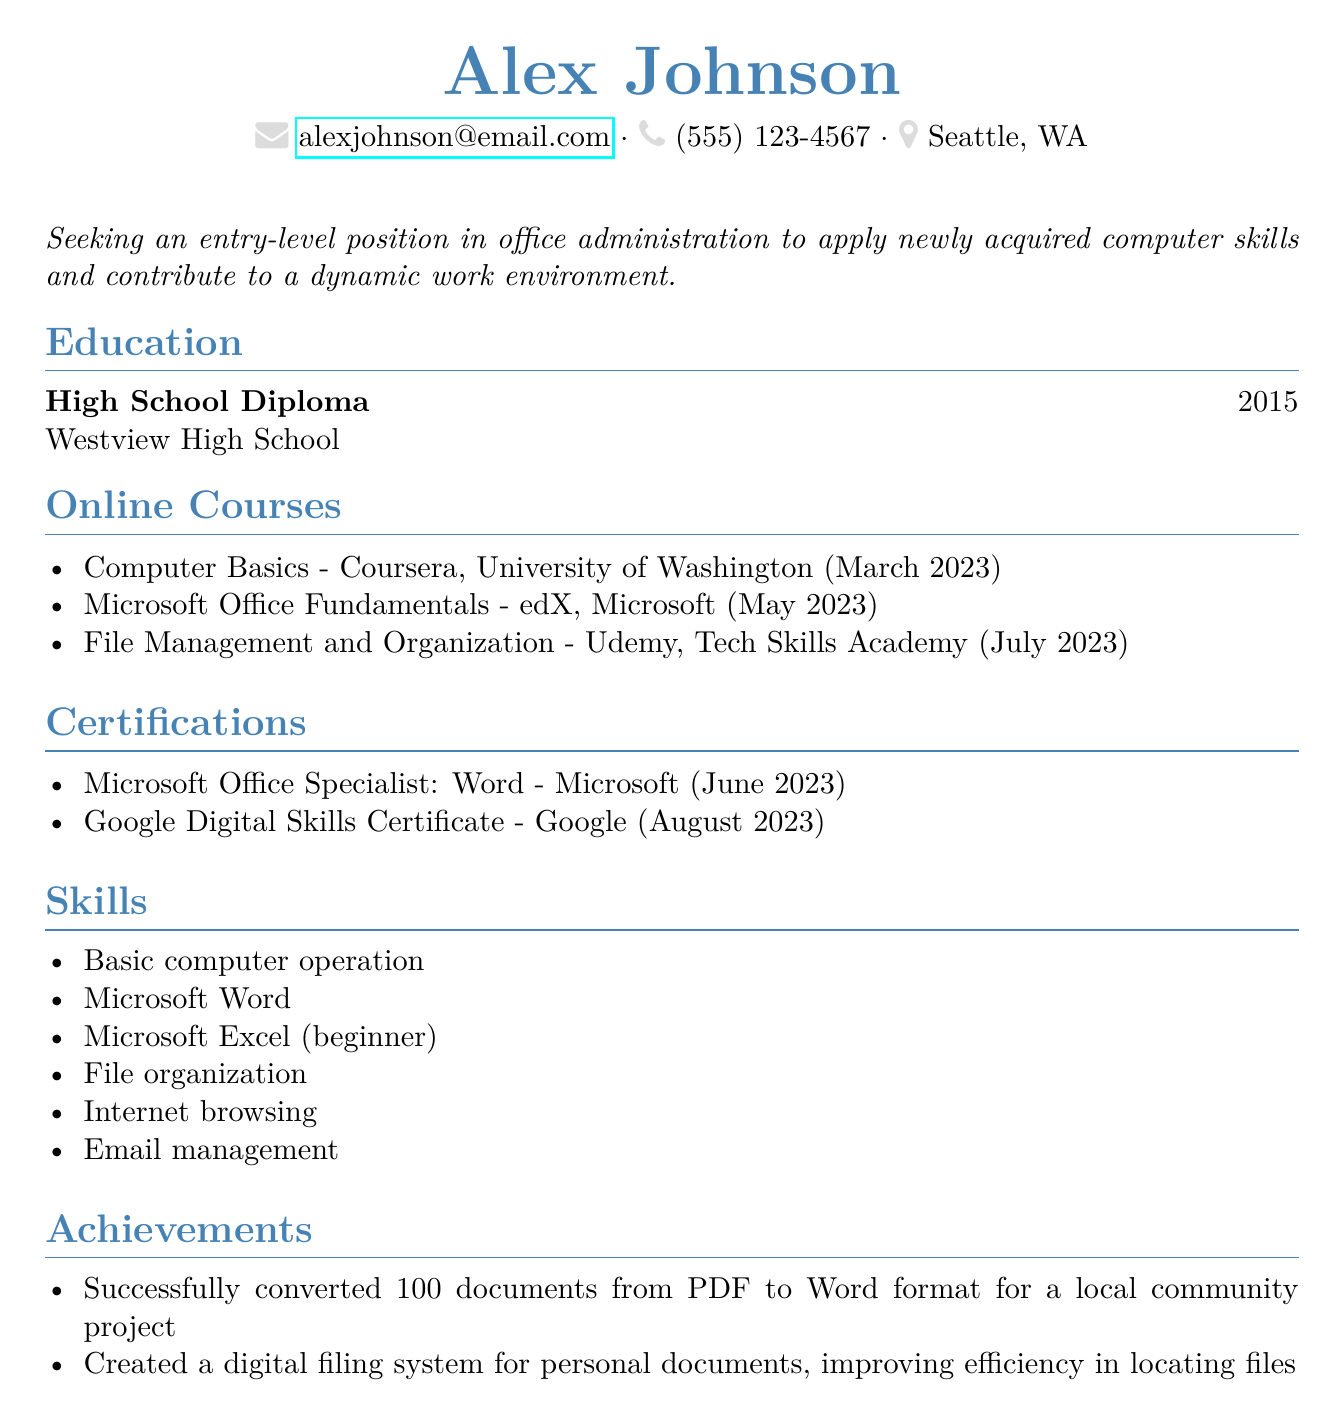What is the name of the person? The name of the person is provided at the top of the document, listed as Alex Johnson.
Answer: Alex Johnson Which online course was completed in July 2023? The document lists various online courses along with their completion dates, identifying "File Management and Organization" as the one completed in July 2023.
Answer: File Management and Organization What certification was earned from Microsoft? One of the certifications is specifically from Microsoft, identified as "Microsoft Office Specialist: Word."
Answer: Microsoft Office Specialist: Word What is the completion date of the "Computer Basics" course? The completion date for the "Computer Basics" course is stated as March 2023 in the online courses section.
Answer: March 2023 How many achievements are listed in the document? The achievements section contains a total of two specific achievements, providing a count of the items listed.
Answer: 2 What is Alex's objective stated in the CV? The objective section contains a specific statement regarding the position Alex seeks and the skills they wish to apply: "Seeking an entry-level position in office administration to apply newly acquired computer skills and contribute to a dynamic work environment."
Answer: Seeking an entry-level position in office administration to apply newly acquired computer skills and contribute to a dynamic work environment Which platform hosted the course "Microsoft Office Fundamentals"? The document specifies the platform associated with the "Microsoft Office Fundamentals" course, indicating it was hosted on edX.
Answer: edX What skill level is Alex in Microsoft Excel? The skills section describes Alex's proficiency in Microsoft Excel, indicating they are a beginner.
Answer: beginner 